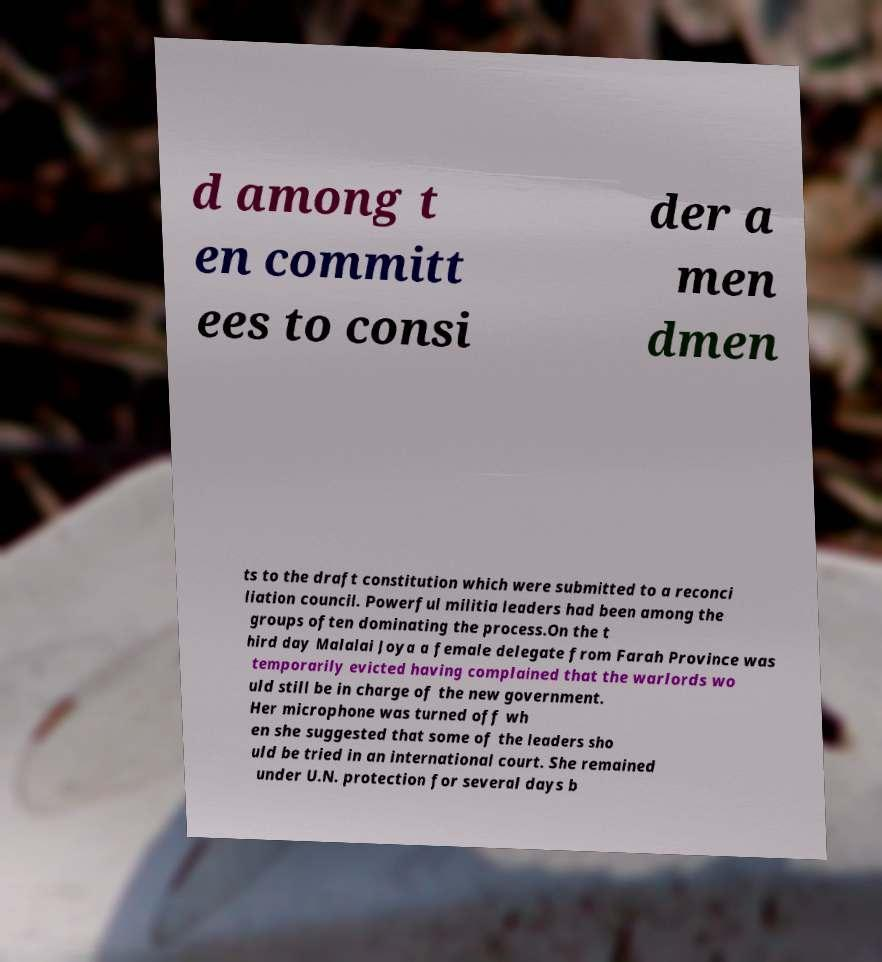Can you accurately transcribe the text from the provided image for me? d among t en committ ees to consi der a men dmen ts to the draft constitution which were submitted to a reconci liation council. Powerful militia leaders had been among the groups often dominating the process.On the t hird day Malalai Joya a female delegate from Farah Province was temporarily evicted having complained that the warlords wo uld still be in charge of the new government. Her microphone was turned off wh en she suggested that some of the leaders sho uld be tried in an international court. She remained under U.N. protection for several days b 